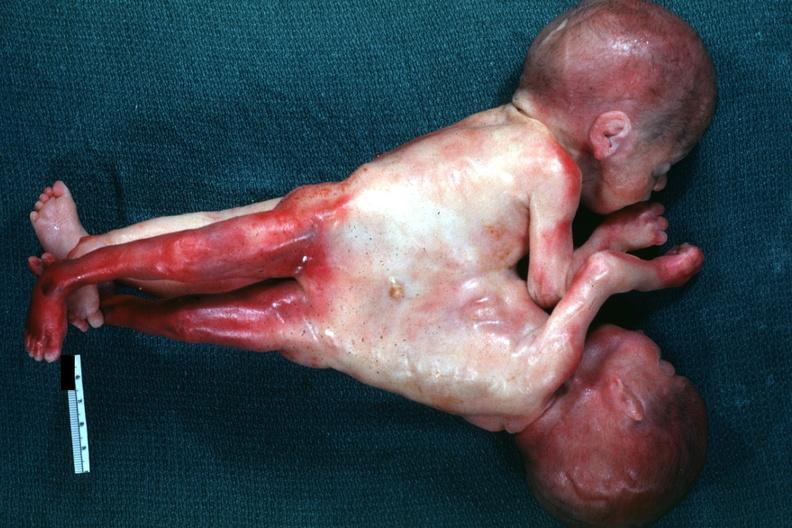what is present?
Answer the question using a single word or phrase. Siamese twins 